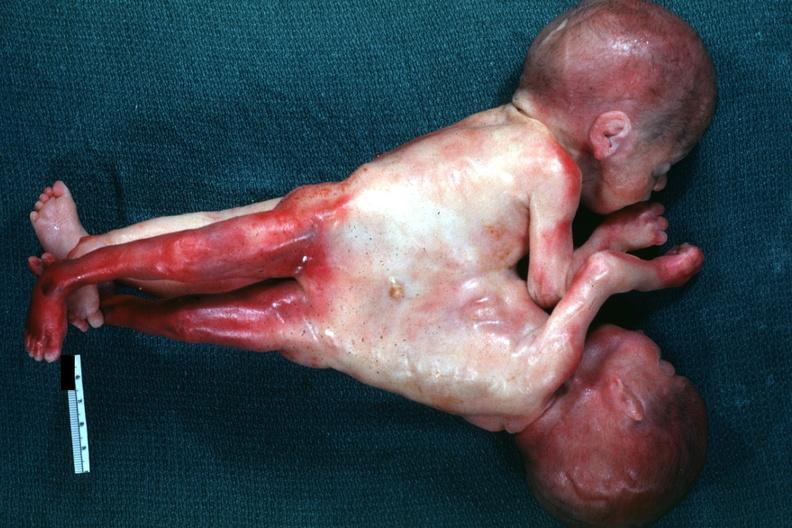what is present?
Answer the question using a single word or phrase. Siamese twins 